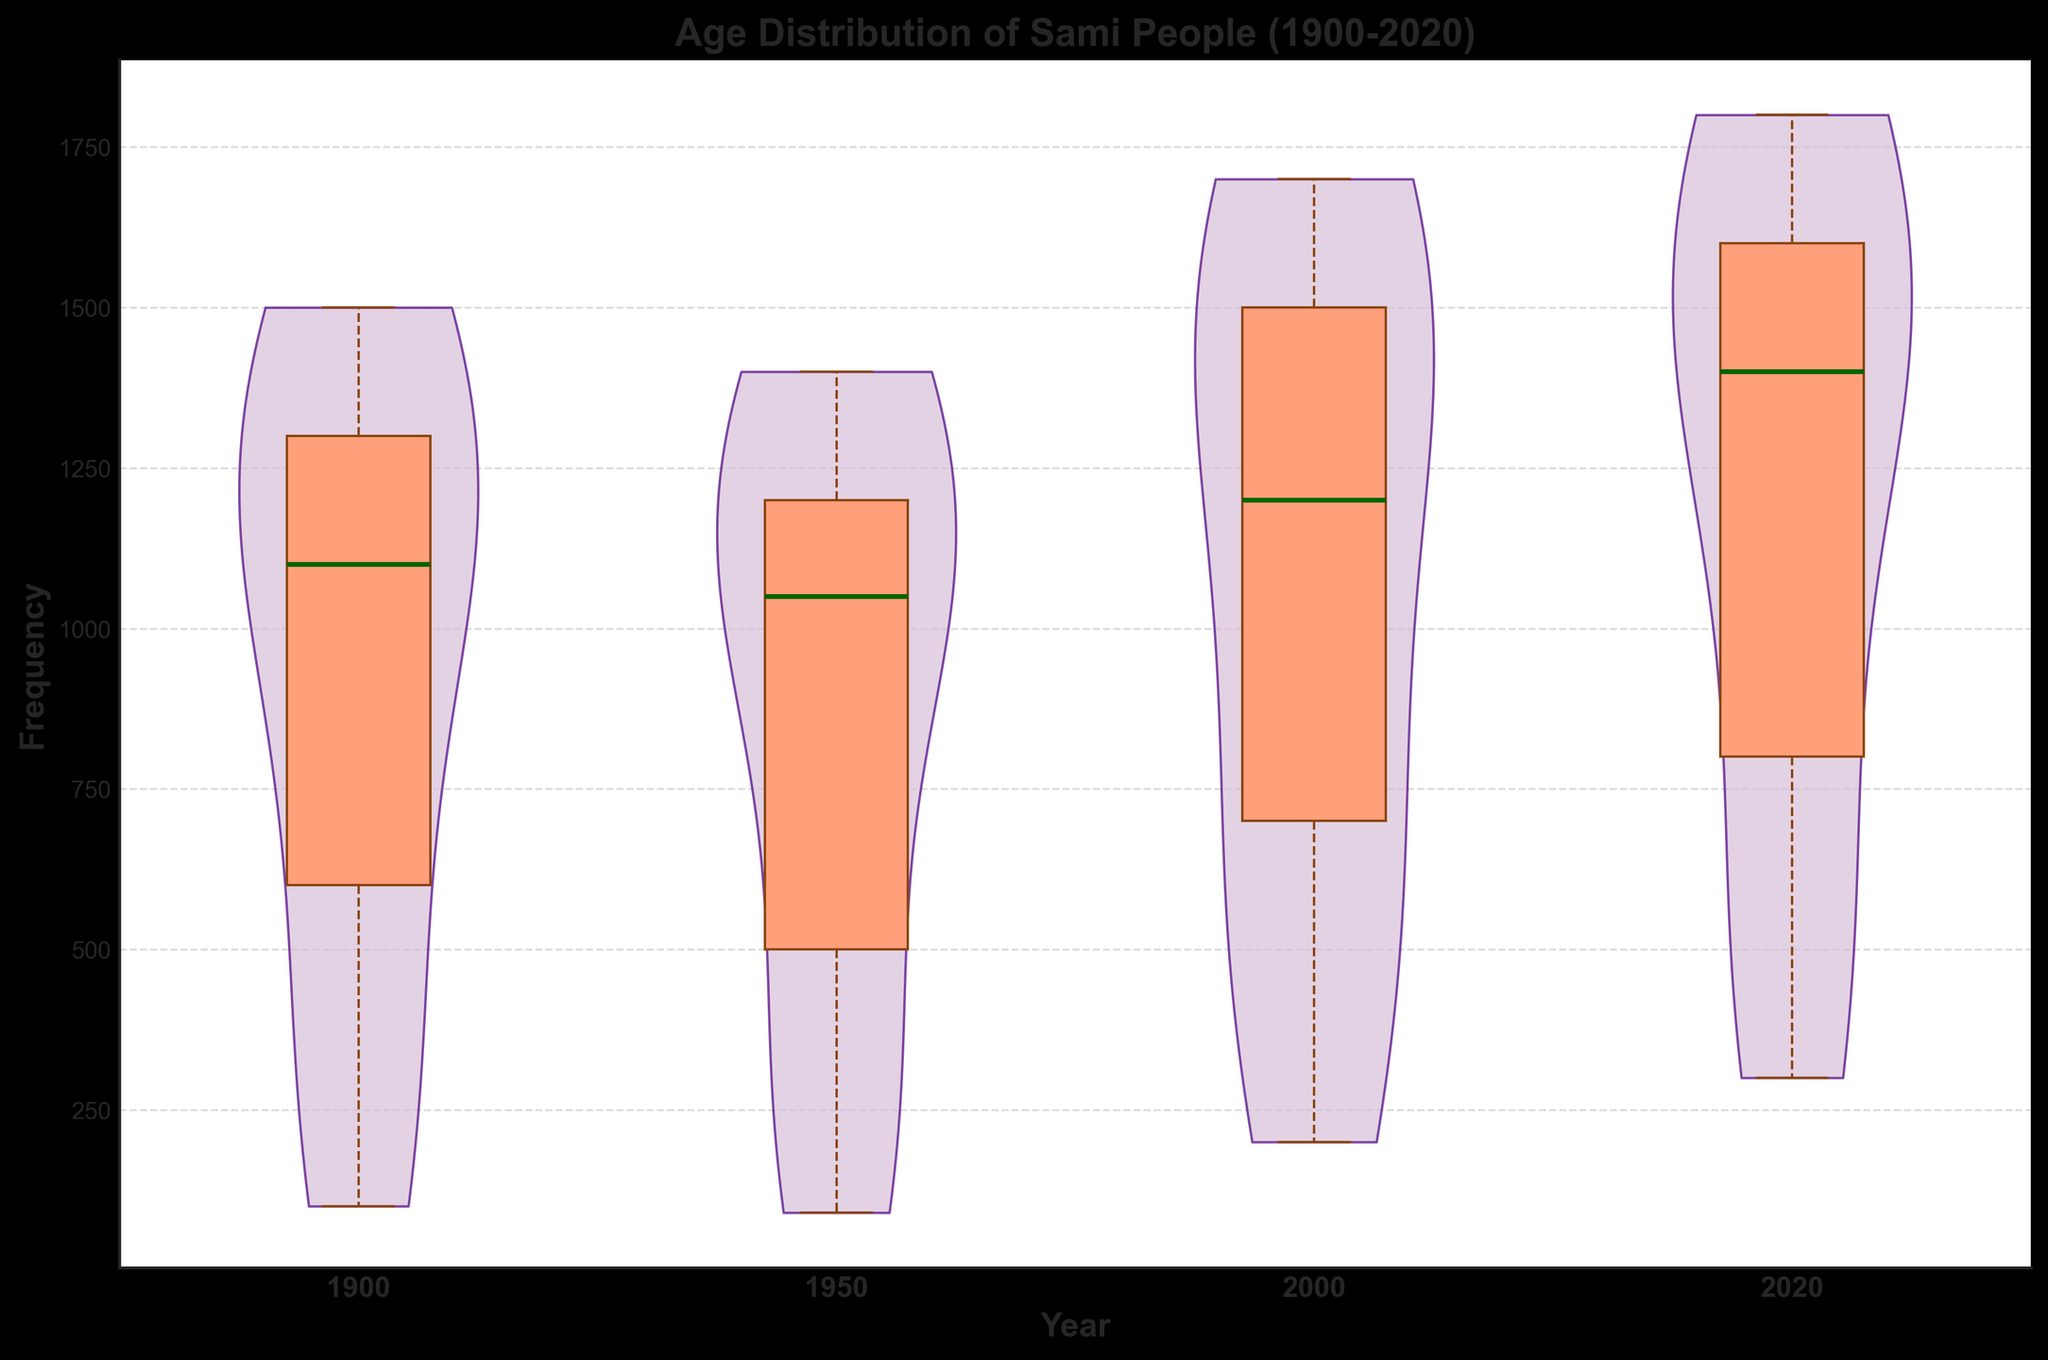Which year has the highest age group frequency for 0-9 years? Look at the violin distribution and the box plot overlay for the age group 0-9 in each year. Identify the year with the tallest distribution for this age group.
Answer: 2020 How has the median frequency of age groups changed from 1900 to 2020? Check the median line in the box plots of the years 1900 and 2020. Compare the median frequencies for both years to determine if there’s an increase or decrease.
Answer: Increased Which year shows the widest distribution of frequency for all age groups combined? Evaluate the spread of the violin plots across all age groups for each year. The year with the most varied violin widths will have the widest distribution.
Answer: 2020 In which year does the frequency of elder age groups (70-79 and 80+) show significant growth compared to earlier periods? Compare the height of the violin distributions and the box plot overlays for the age groups 70-79 and 80+ across all years. Identify the year where these age groups have noticeably larger frequencies.
Answer: 2020 What is the trend in frequency for the 60-69 age group from 1900 to 2020? Follow the distribution height and box plot medians for the 60-69 age group across all years. Check if the frequencies increase, decrease, or remain stable over time.
Answer: Increased Which age group shows the most significant increase in frequency from 1900 to 2020? Analyze the violin and box plot distributions for each age group from 1900 to 2020. Identify the age group where the frequency has increased the most.
Answer: 0-9 years How do the distributions in 1950 compare to those in 2000 for middle-aged groups (40-49)? Analyze the violin plot widths and box plot medians for the age group 40-49 in the years 1950 and 2000. Compare the spread and median of the datasets.
Answer: Higher in 2000 Between 1950 and 2000, which year has a more balanced age distribution? Observe the spread of violin plots and box plot overlays for each age group in the years 1950 and 2000. Determine which year has more evenly distributed frequencies across all age groups.
Answer: 1950 Which age group has the smallest frequency spread in 2020? Check the violin plot and box plot for 2020 and identify the age group with the narrowest distribution and smallest interquartile range.
Answer: 50-59 years 